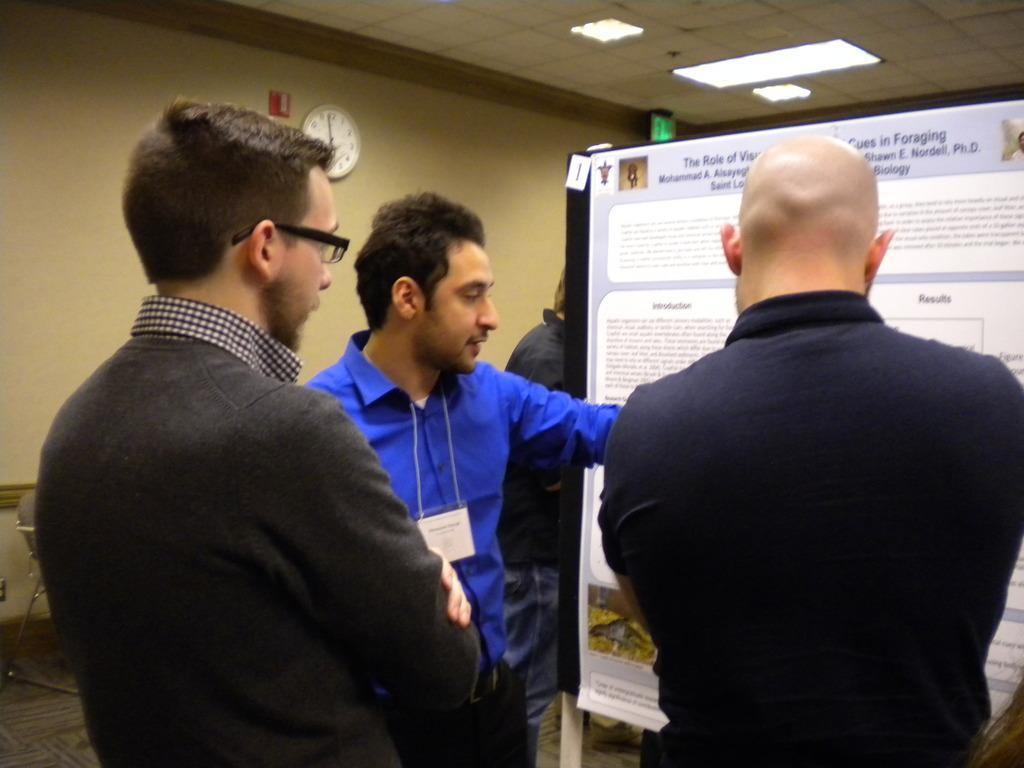Can you describe this image briefly? To the right corner of the image there is a man with black t-shirt is standing. And beside him there is a man with black jacket and kept spectacles. In front of him there is a man with blue t-shirt is standing. In front of them there is a poster. And in the background there is a wall with the clock. And on the top of the roof there is a light. 